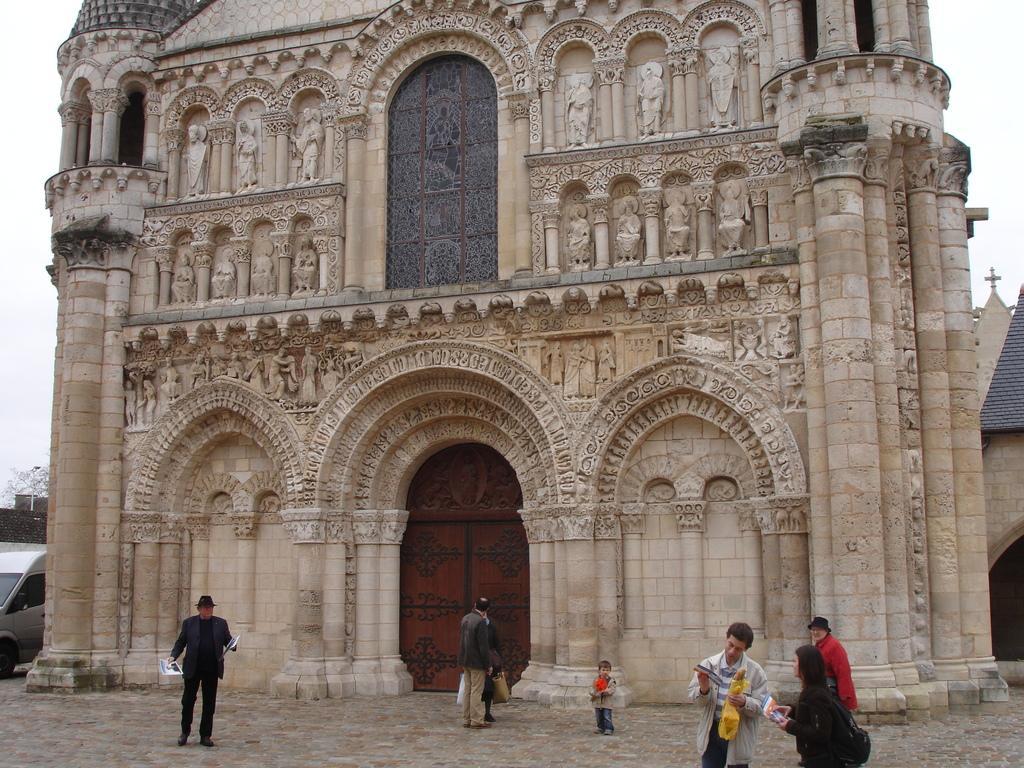Can you describe this image briefly? In the center of the image we can see building and door. At the bottom of the image we can see car and persons. In the background we can see sky. 